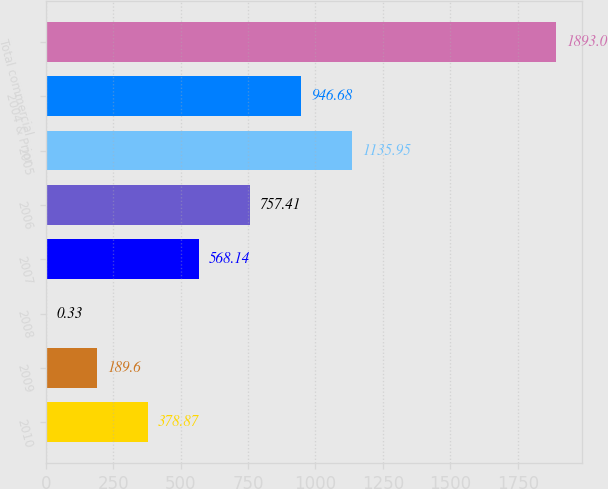Convert chart. <chart><loc_0><loc_0><loc_500><loc_500><bar_chart><fcel>2010<fcel>2009<fcel>2008<fcel>2007<fcel>2006<fcel>2005<fcel>2004 & Prior<fcel>Total commercial<nl><fcel>378.87<fcel>189.6<fcel>0.33<fcel>568.14<fcel>757.41<fcel>1135.95<fcel>946.68<fcel>1893<nl></chart> 